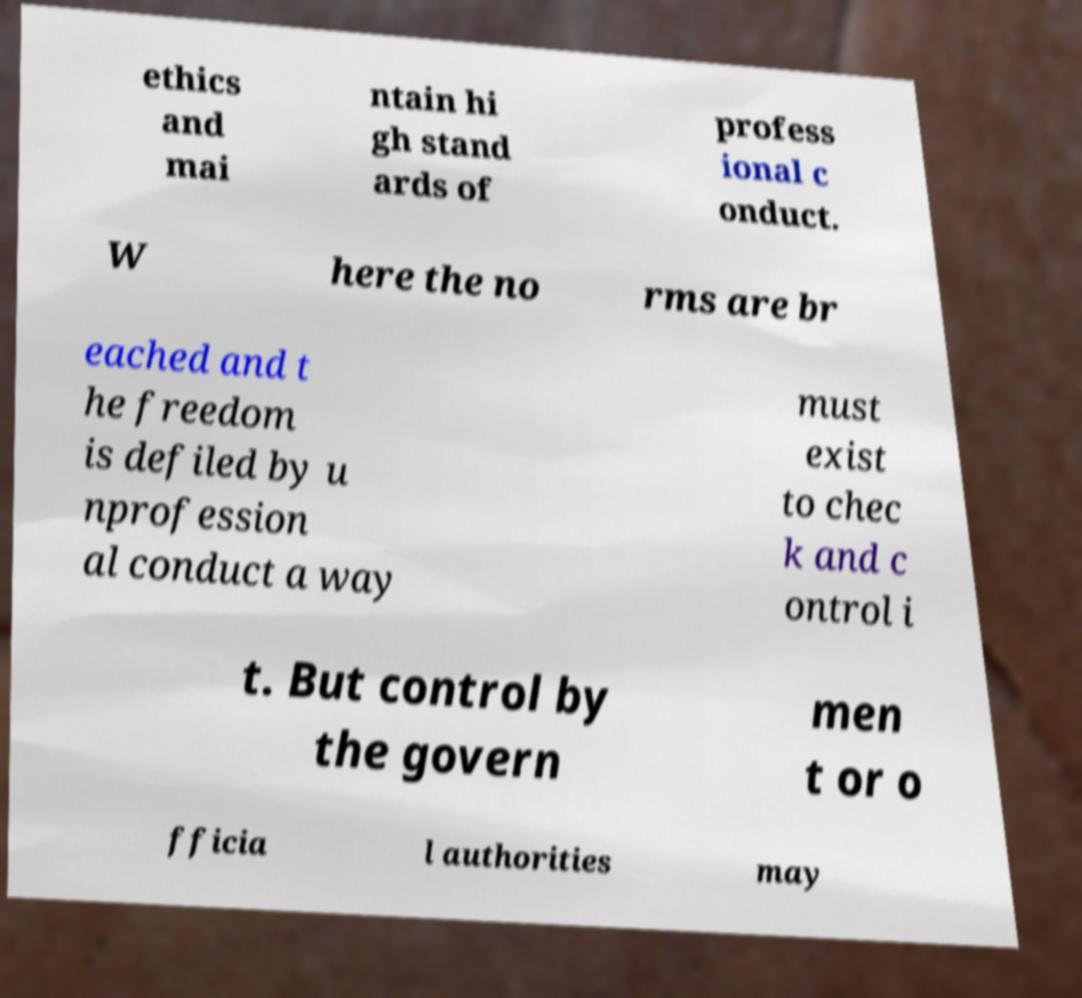What messages or text are displayed in this image? I need them in a readable, typed format. ethics and mai ntain hi gh stand ards of profess ional c onduct. W here the no rms are br eached and t he freedom is defiled by u nprofession al conduct a way must exist to chec k and c ontrol i t. But control by the govern men t or o fficia l authorities may 